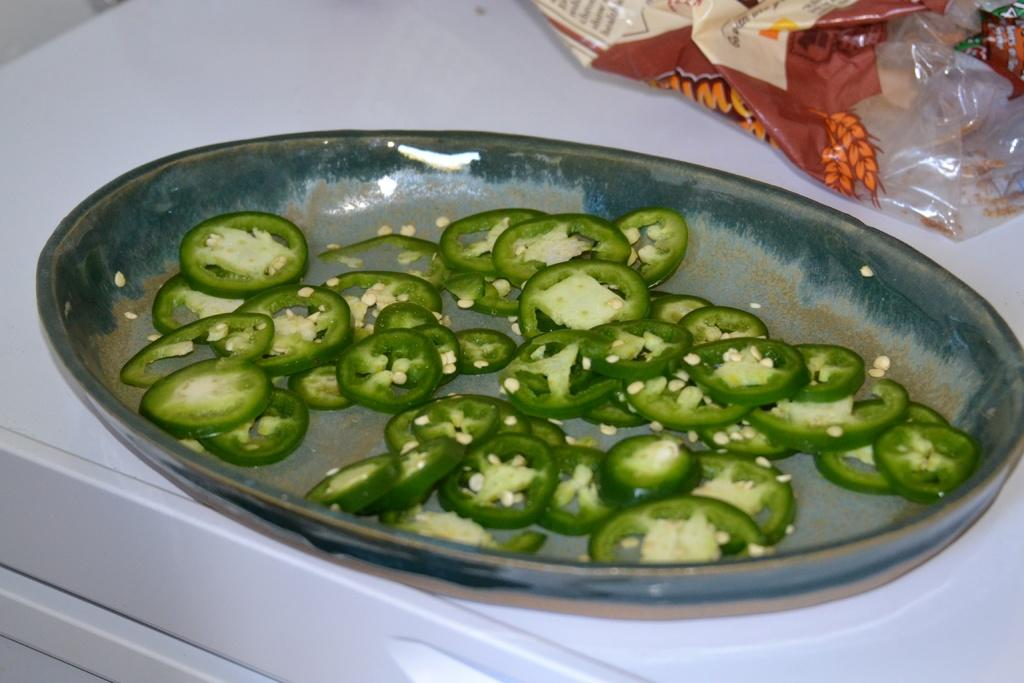What type of food can be seen in the image? There are pieces of capsicums in the image. What is located in the background of the image? There is a plate in the background of the image. What is covering the plate? There is a plastic cover on the plate. Is there any text or information on the plastic cover? Yes, something is written on the plastic cover. How does the capsicum help with digestion in the image? The image does not show any information about the capsicum's effect on digestion, nor does it depict any digestive process. 